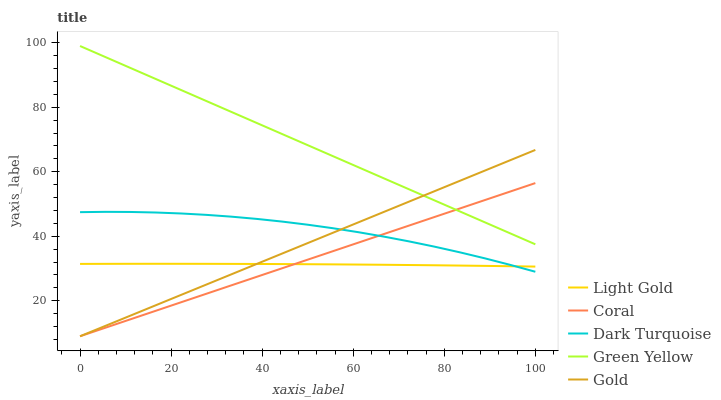Does Light Gold have the minimum area under the curve?
Answer yes or no. Yes. Does Green Yellow have the maximum area under the curve?
Answer yes or no. Yes. Does Coral have the minimum area under the curve?
Answer yes or no. No. Does Coral have the maximum area under the curve?
Answer yes or no. No. Is Coral the smoothest?
Answer yes or no. Yes. Is Dark Turquoise the roughest?
Answer yes or no. Yes. Is Green Yellow the smoothest?
Answer yes or no. No. Is Green Yellow the roughest?
Answer yes or no. No. Does Coral have the lowest value?
Answer yes or no. Yes. Does Green Yellow have the lowest value?
Answer yes or no. No. Does Green Yellow have the highest value?
Answer yes or no. Yes. Does Coral have the highest value?
Answer yes or no. No. Is Dark Turquoise less than Green Yellow?
Answer yes or no. Yes. Is Green Yellow greater than Dark Turquoise?
Answer yes or no. Yes. Does Coral intersect Gold?
Answer yes or no. Yes. Is Coral less than Gold?
Answer yes or no. No. Is Coral greater than Gold?
Answer yes or no. No. Does Dark Turquoise intersect Green Yellow?
Answer yes or no. No. 